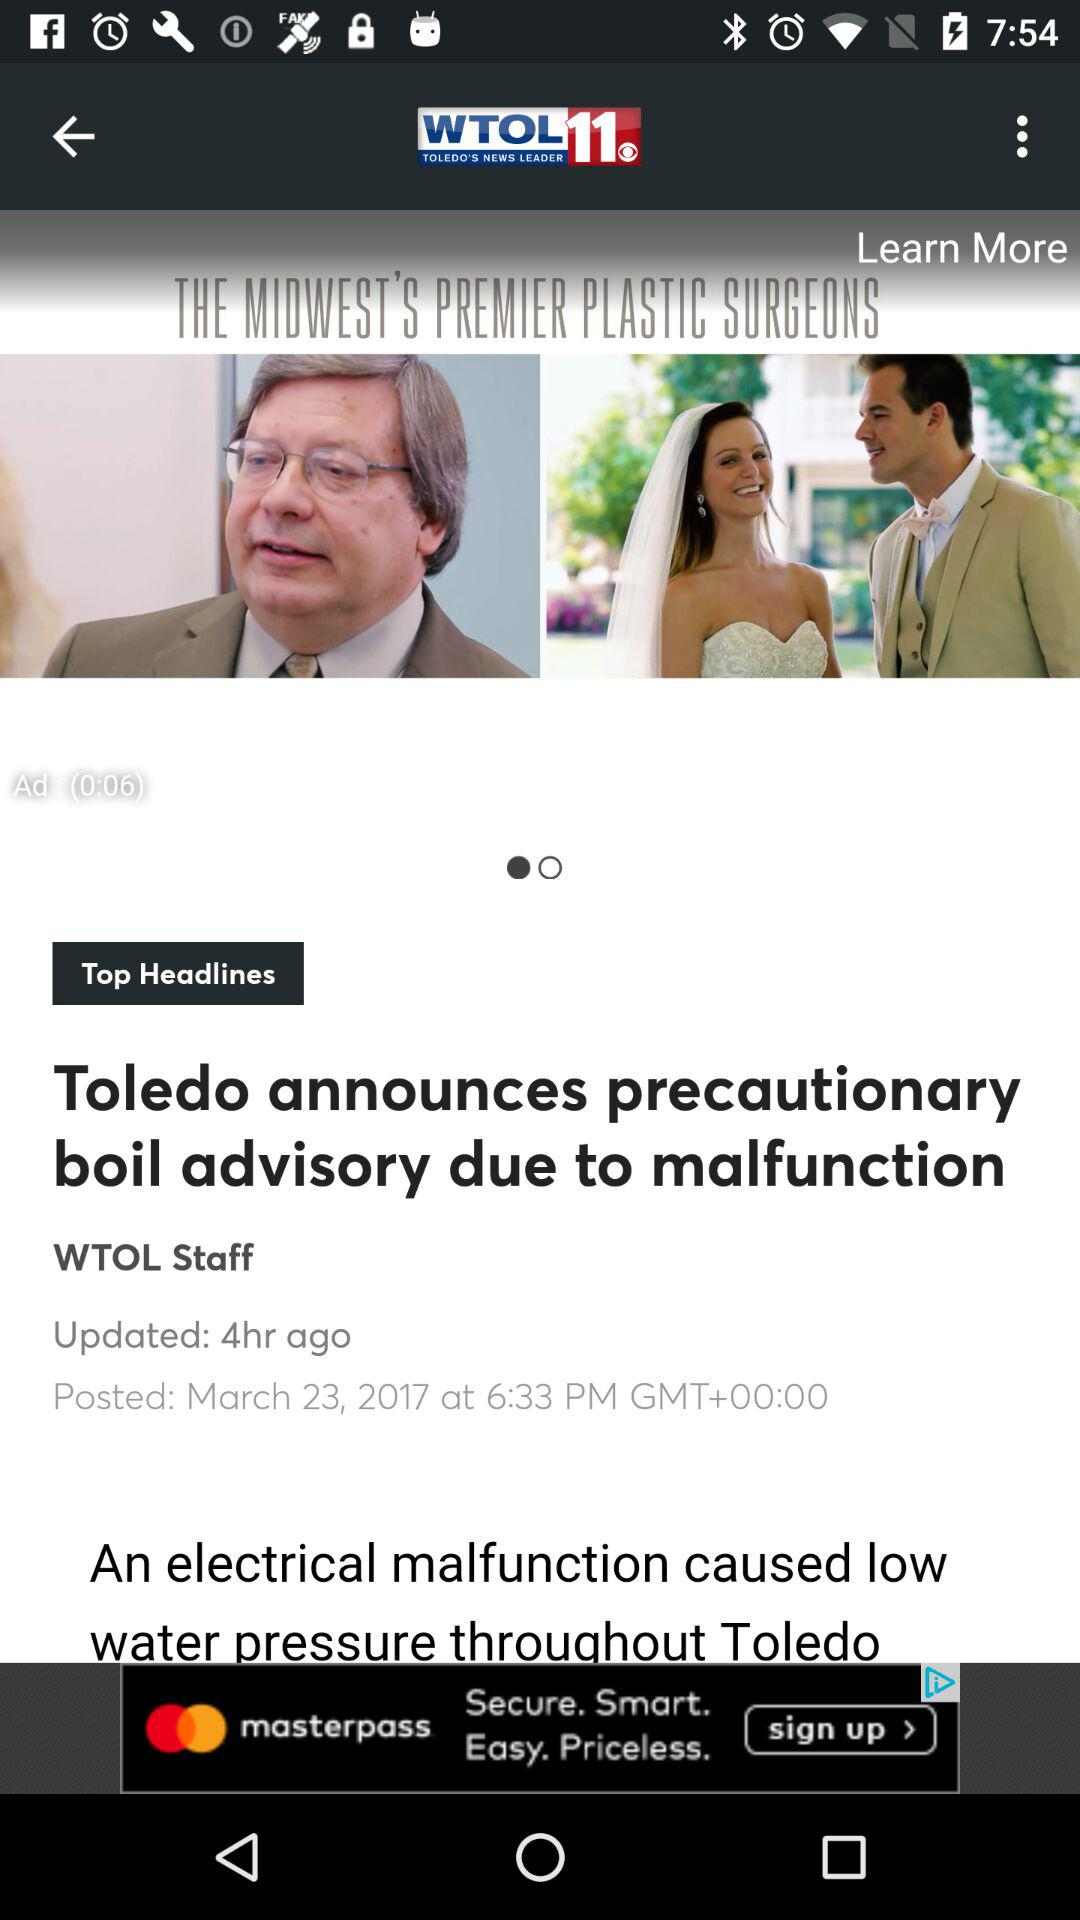Who posted the news about Toledo announcing a precautionary boil advisory due to a malfunction? The news was posted by "WTOL" staff. 